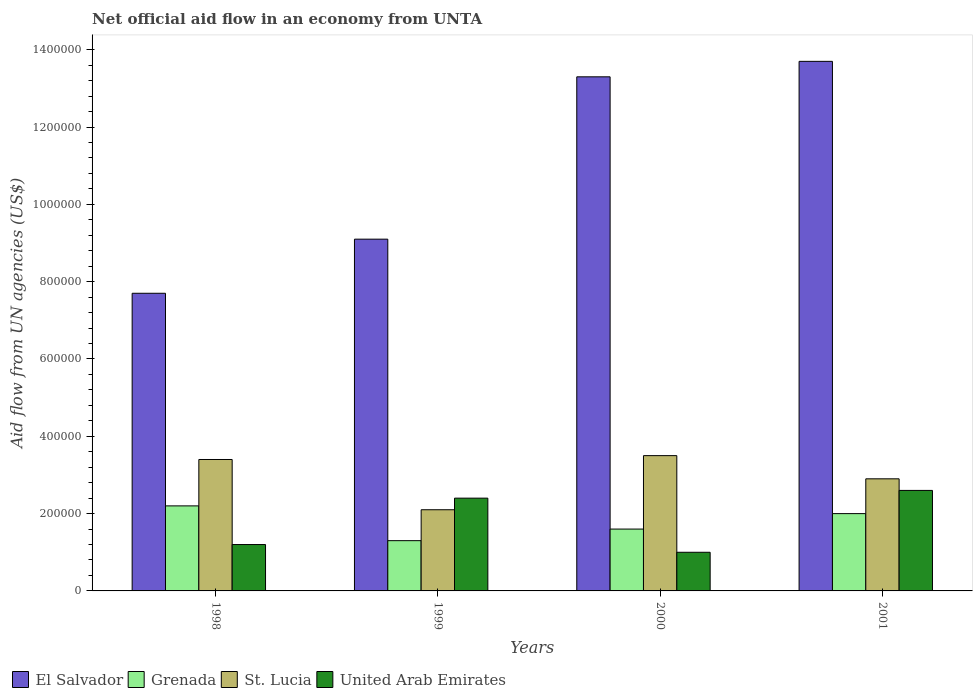How many groups of bars are there?
Give a very brief answer. 4. Are the number of bars per tick equal to the number of legend labels?
Ensure brevity in your answer.  Yes. How many bars are there on the 4th tick from the right?
Give a very brief answer. 4. What is the label of the 3rd group of bars from the left?
Offer a very short reply. 2000. In how many cases, is the number of bars for a given year not equal to the number of legend labels?
Your response must be concise. 0. Across all years, what is the maximum net official aid flow in El Salvador?
Your response must be concise. 1.37e+06. What is the total net official aid flow in Grenada in the graph?
Offer a very short reply. 7.10e+05. What is the difference between the net official aid flow in Grenada in 2000 and the net official aid flow in United Arab Emirates in 2001?
Provide a short and direct response. -1.00e+05. What is the average net official aid flow in United Arab Emirates per year?
Ensure brevity in your answer.  1.80e+05. In the year 2000, what is the difference between the net official aid flow in St. Lucia and net official aid flow in El Salvador?
Make the answer very short. -9.80e+05. In how many years, is the net official aid flow in United Arab Emirates greater than 1160000 US$?
Offer a terse response. 0. What is the ratio of the net official aid flow in El Salvador in 1999 to that in 2000?
Your response must be concise. 0.68. Is the difference between the net official aid flow in St. Lucia in 1999 and 2000 greater than the difference between the net official aid flow in El Salvador in 1999 and 2000?
Your answer should be very brief. Yes. What is the difference between the highest and the second highest net official aid flow in Grenada?
Make the answer very short. 2.00e+04. What is the difference between the highest and the lowest net official aid flow in El Salvador?
Ensure brevity in your answer.  6.00e+05. In how many years, is the net official aid flow in United Arab Emirates greater than the average net official aid flow in United Arab Emirates taken over all years?
Your answer should be very brief. 2. Is it the case that in every year, the sum of the net official aid flow in Grenada and net official aid flow in El Salvador is greater than the sum of net official aid flow in United Arab Emirates and net official aid flow in St. Lucia?
Your answer should be very brief. No. What does the 1st bar from the left in 2001 represents?
Offer a terse response. El Salvador. What does the 4th bar from the right in 1998 represents?
Provide a succinct answer. El Salvador. How many bars are there?
Offer a terse response. 16. How many years are there in the graph?
Give a very brief answer. 4. What is the difference between two consecutive major ticks on the Y-axis?
Provide a succinct answer. 2.00e+05. How are the legend labels stacked?
Your answer should be compact. Horizontal. What is the title of the graph?
Offer a terse response. Net official aid flow in an economy from UNTA. What is the label or title of the X-axis?
Your response must be concise. Years. What is the label or title of the Y-axis?
Give a very brief answer. Aid flow from UN agencies (US$). What is the Aid flow from UN agencies (US$) of El Salvador in 1998?
Provide a short and direct response. 7.70e+05. What is the Aid flow from UN agencies (US$) of St. Lucia in 1998?
Offer a terse response. 3.40e+05. What is the Aid flow from UN agencies (US$) of United Arab Emirates in 1998?
Your answer should be very brief. 1.20e+05. What is the Aid flow from UN agencies (US$) of El Salvador in 1999?
Offer a terse response. 9.10e+05. What is the Aid flow from UN agencies (US$) in Grenada in 1999?
Offer a terse response. 1.30e+05. What is the Aid flow from UN agencies (US$) of El Salvador in 2000?
Give a very brief answer. 1.33e+06. What is the Aid flow from UN agencies (US$) in Grenada in 2000?
Your answer should be compact. 1.60e+05. What is the Aid flow from UN agencies (US$) in United Arab Emirates in 2000?
Provide a short and direct response. 1.00e+05. What is the Aid flow from UN agencies (US$) of El Salvador in 2001?
Provide a succinct answer. 1.37e+06. What is the Aid flow from UN agencies (US$) in Grenada in 2001?
Keep it short and to the point. 2.00e+05. What is the Aid flow from UN agencies (US$) of United Arab Emirates in 2001?
Make the answer very short. 2.60e+05. Across all years, what is the maximum Aid flow from UN agencies (US$) of El Salvador?
Your answer should be compact. 1.37e+06. Across all years, what is the maximum Aid flow from UN agencies (US$) in United Arab Emirates?
Offer a terse response. 2.60e+05. Across all years, what is the minimum Aid flow from UN agencies (US$) of El Salvador?
Offer a terse response. 7.70e+05. Across all years, what is the minimum Aid flow from UN agencies (US$) in St. Lucia?
Provide a short and direct response. 2.10e+05. Across all years, what is the minimum Aid flow from UN agencies (US$) in United Arab Emirates?
Offer a very short reply. 1.00e+05. What is the total Aid flow from UN agencies (US$) of El Salvador in the graph?
Offer a terse response. 4.38e+06. What is the total Aid flow from UN agencies (US$) of Grenada in the graph?
Provide a succinct answer. 7.10e+05. What is the total Aid flow from UN agencies (US$) of St. Lucia in the graph?
Your answer should be compact. 1.19e+06. What is the total Aid flow from UN agencies (US$) in United Arab Emirates in the graph?
Provide a short and direct response. 7.20e+05. What is the difference between the Aid flow from UN agencies (US$) in El Salvador in 1998 and that in 1999?
Offer a terse response. -1.40e+05. What is the difference between the Aid flow from UN agencies (US$) in El Salvador in 1998 and that in 2000?
Keep it short and to the point. -5.60e+05. What is the difference between the Aid flow from UN agencies (US$) of El Salvador in 1998 and that in 2001?
Your answer should be very brief. -6.00e+05. What is the difference between the Aid flow from UN agencies (US$) in Grenada in 1998 and that in 2001?
Your answer should be compact. 2.00e+04. What is the difference between the Aid flow from UN agencies (US$) in St. Lucia in 1998 and that in 2001?
Your answer should be compact. 5.00e+04. What is the difference between the Aid flow from UN agencies (US$) of United Arab Emirates in 1998 and that in 2001?
Offer a very short reply. -1.40e+05. What is the difference between the Aid flow from UN agencies (US$) of El Salvador in 1999 and that in 2000?
Your answer should be compact. -4.20e+05. What is the difference between the Aid flow from UN agencies (US$) of St. Lucia in 1999 and that in 2000?
Your answer should be compact. -1.40e+05. What is the difference between the Aid flow from UN agencies (US$) of El Salvador in 1999 and that in 2001?
Your response must be concise. -4.60e+05. What is the difference between the Aid flow from UN agencies (US$) of El Salvador in 2000 and that in 2001?
Give a very brief answer. -4.00e+04. What is the difference between the Aid flow from UN agencies (US$) in Grenada in 2000 and that in 2001?
Your response must be concise. -4.00e+04. What is the difference between the Aid flow from UN agencies (US$) of El Salvador in 1998 and the Aid flow from UN agencies (US$) of Grenada in 1999?
Provide a short and direct response. 6.40e+05. What is the difference between the Aid flow from UN agencies (US$) in El Salvador in 1998 and the Aid flow from UN agencies (US$) in St. Lucia in 1999?
Your answer should be compact. 5.60e+05. What is the difference between the Aid flow from UN agencies (US$) in El Salvador in 1998 and the Aid flow from UN agencies (US$) in United Arab Emirates in 1999?
Offer a terse response. 5.30e+05. What is the difference between the Aid flow from UN agencies (US$) of Grenada in 1998 and the Aid flow from UN agencies (US$) of United Arab Emirates in 1999?
Ensure brevity in your answer.  -2.00e+04. What is the difference between the Aid flow from UN agencies (US$) in El Salvador in 1998 and the Aid flow from UN agencies (US$) in St. Lucia in 2000?
Your answer should be compact. 4.20e+05. What is the difference between the Aid flow from UN agencies (US$) in El Salvador in 1998 and the Aid flow from UN agencies (US$) in United Arab Emirates in 2000?
Provide a short and direct response. 6.70e+05. What is the difference between the Aid flow from UN agencies (US$) of St. Lucia in 1998 and the Aid flow from UN agencies (US$) of United Arab Emirates in 2000?
Provide a succinct answer. 2.40e+05. What is the difference between the Aid flow from UN agencies (US$) of El Salvador in 1998 and the Aid flow from UN agencies (US$) of Grenada in 2001?
Give a very brief answer. 5.70e+05. What is the difference between the Aid flow from UN agencies (US$) of El Salvador in 1998 and the Aid flow from UN agencies (US$) of St. Lucia in 2001?
Your answer should be very brief. 4.80e+05. What is the difference between the Aid flow from UN agencies (US$) of El Salvador in 1998 and the Aid flow from UN agencies (US$) of United Arab Emirates in 2001?
Offer a terse response. 5.10e+05. What is the difference between the Aid flow from UN agencies (US$) of Grenada in 1998 and the Aid flow from UN agencies (US$) of United Arab Emirates in 2001?
Your answer should be very brief. -4.00e+04. What is the difference between the Aid flow from UN agencies (US$) of El Salvador in 1999 and the Aid flow from UN agencies (US$) of Grenada in 2000?
Provide a succinct answer. 7.50e+05. What is the difference between the Aid flow from UN agencies (US$) in El Salvador in 1999 and the Aid flow from UN agencies (US$) in St. Lucia in 2000?
Your answer should be very brief. 5.60e+05. What is the difference between the Aid flow from UN agencies (US$) in El Salvador in 1999 and the Aid flow from UN agencies (US$) in United Arab Emirates in 2000?
Provide a short and direct response. 8.10e+05. What is the difference between the Aid flow from UN agencies (US$) in Grenada in 1999 and the Aid flow from UN agencies (US$) in United Arab Emirates in 2000?
Your answer should be very brief. 3.00e+04. What is the difference between the Aid flow from UN agencies (US$) of St. Lucia in 1999 and the Aid flow from UN agencies (US$) of United Arab Emirates in 2000?
Your answer should be compact. 1.10e+05. What is the difference between the Aid flow from UN agencies (US$) of El Salvador in 1999 and the Aid flow from UN agencies (US$) of Grenada in 2001?
Keep it short and to the point. 7.10e+05. What is the difference between the Aid flow from UN agencies (US$) in El Salvador in 1999 and the Aid flow from UN agencies (US$) in St. Lucia in 2001?
Your response must be concise. 6.20e+05. What is the difference between the Aid flow from UN agencies (US$) of El Salvador in 1999 and the Aid flow from UN agencies (US$) of United Arab Emirates in 2001?
Your answer should be compact. 6.50e+05. What is the difference between the Aid flow from UN agencies (US$) in Grenada in 1999 and the Aid flow from UN agencies (US$) in St. Lucia in 2001?
Ensure brevity in your answer.  -1.60e+05. What is the difference between the Aid flow from UN agencies (US$) of Grenada in 1999 and the Aid flow from UN agencies (US$) of United Arab Emirates in 2001?
Give a very brief answer. -1.30e+05. What is the difference between the Aid flow from UN agencies (US$) in El Salvador in 2000 and the Aid flow from UN agencies (US$) in Grenada in 2001?
Provide a short and direct response. 1.13e+06. What is the difference between the Aid flow from UN agencies (US$) of El Salvador in 2000 and the Aid flow from UN agencies (US$) of St. Lucia in 2001?
Your answer should be very brief. 1.04e+06. What is the difference between the Aid flow from UN agencies (US$) of El Salvador in 2000 and the Aid flow from UN agencies (US$) of United Arab Emirates in 2001?
Provide a succinct answer. 1.07e+06. What is the difference between the Aid flow from UN agencies (US$) of St. Lucia in 2000 and the Aid flow from UN agencies (US$) of United Arab Emirates in 2001?
Provide a short and direct response. 9.00e+04. What is the average Aid flow from UN agencies (US$) of El Salvador per year?
Make the answer very short. 1.10e+06. What is the average Aid flow from UN agencies (US$) of Grenada per year?
Offer a terse response. 1.78e+05. What is the average Aid flow from UN agencies (US$) of St. Lucia per year?
Provide a succinct answer. 2.98e+05. In the year 1998, what is the difference between the Aid flow from UN agencies (US$) in El Salvador and Aid flow from UN agencies (US$) in Grenada?
Give a very brief answer. 5.50e+05. In the year 1998, what is the difference between the Aid flow from UN agencies (US$) of El Salvador and Aid flow from UN agencies (US$) of St. Lucia?
Make the answer very short. 4.30e+05. In the year 1998, what is the difference between the Aid flow from UN agencies (US$) in El Salvador and Aid flow from UN agencies (US$) in United Arab Emirates?
Provide a succinct answer. 6.50e+05. In the year 1998, what is the difference between the Aid flow from UN agencies (US$) in Grenada and Aid flow from UN agencies (US$) in United Arab Emirates?
Your response must be concise. 1.00e+05. In the year 1999, what is the difference between the Aid flow from UN agencies (US$) in El Salvador and Aid flow from UN agencies (US$) in Grenada?
Give a very brief answer. 7.80e+05. In the year 1999, what is the difference between the Aid flow from UN agencies (US$) of El Salvador and Aid flow from UN agencies (US$) of St. Lucia?
Your response must be concise. 7.00e+05. In the year 1999, what is the difference between the Aid flow from UN agencies (US$) of El Salvador and Aid flow from UN agencies (US$) of United Arab Emirates?
Your response must be concise. 6.70e+05. In the year 1999, what is the difference between the Aid flow from UN agencies (US$) of Grenada and Aid flow from UN agencies (US$) of United Arab Emirates?
Make the answer very short. -1.10e+05. In the year 2000, what is the difference between the Aid flow from UN agencies (US$) in El Salvador and Aid flow from UN agencies (US$) in Grenada?
Offer a terse response. 1.17e+06. In the year 2000, what is the difference between the Aid flow from UN agencies (US$) in El Salvador and Aid flow from UN agencies (US$) in St. Lucia?
Your answer should be very brief. 9.80e+05. In the year 2000, what is the difference between the Aid flow from UN agencies (US$) of El Salvador and Aid flow from UN agencies (US$) of United Arab Emirates?
Make the answer very short. 1.23e+06. In the year 2000, what is the difference between the Aid flow from UN agencies (US$) of Grenada and Aid flow from UN agencies (US$) of St. Lucia?
Offer a terse response. -1.90e+05. In the year 2000, what is the difference between the Aid flow from UN agencies (US$) in Grenada and Aid flow from UN agencies (US$) in United Arab Emirates?
Give a very brief answer. 6.00e+04. In the year 2000, what is the difference between the Aid flow from UN agencies (US$) in St. Lucia and Aid flow from UN agencies (US$) in United Arab Emirates?
Offer a terse response. 2.50e+05. In the year 2001, what is the difference between the Aid flow from UN agencies (US$) of El Salvador and Aid flow from UN agencies (US$) of Grenada?
Give a very brief answer. 1.17e+06. In the year 2001, what is the difference between the Aid flow from UN agencies (US$) in El Salvador and Aid flow from UN agencies (US$) in St. Lucia?
Make the answer very short. 1.08e+06. In the year 2001, what is the difference between the Aid flow from UN agencies (US$) in El Salvador and Aid flow from UN agencies (US$) in United Arab Emirates?
Make the answer very short. 1.11e+06. In the year 2001, what is the difference between the Aid flow from UN agencies (US$) in Grenada and Aid flow from UN agencies (US$) in United Arab Emirates?
Your answer should be compact. -6.00e+04. What is the ratio of the Aid flow from UN agencies (US$) in El Salvador in 1998 to that in 1999?
Your response must be concise. 0.85. What is the ratio of the Aid flow from UN agencies (US$) in Grenada in 1998 to that in 1999?
Your response must be concise. 1.69. What is the ratio of the Aid flow from UN agencies (US$) in St. Lucia in 1998 to that in 1999?
Your response must be concise. 1.62. What is the ratio of the Aid flow from UN agencies (US$) in United Arab Emirates in 1998 to that in 1999?
Your answer should be very brief. 0.5. What is the ratio of the Aid flow from UN agencies (US$) of El Salvador in 1998 to that in 2000?
Your response must be concise. 0.58. What is the ratio of the Aid flow from UN agencies (US$) of Grenada in 1998 to that in 2000?
Your answer should be very brief. 1.38. What is the ratio of the Aid flow from UN agencies (US$) in St. Lucia in 1998 to that in 2000?
Keep it short and to the point. 0.97. What is the ratio of the Aid flow from UN agencies (US$) in United Arab Emirates in 1998 to that in 2000?
Offer a terse response. 1.2. What is the ratio of the Aid flow from UN agencies (US$) in El Salvador in 1998 to that in 2001?
Keep it short and to the point. 0.56. What is the ratio of the Aid flow from UN agencies (US$) of St. Lucia in 1998 to that in 2001?
Give a very brief answer. 1.17. What is the ratio of the Aid flow from UN agencies (US$) of United Arab Emirates in 1998 to that in 2001?
Keep it short and to the point. 0.46. What is the ratio of the Aid flow from UN agencies (US$) of El Salvador in 1999 to that in 2000?
Make the answer very short. 0.68. What is the ratio of the Aid flow from UN agencies (US$) in Grenada in 1999 to that in 2000?
Keep it short and to the point. 0.81. What is the ratio of the Aid flow from UN agencies (US$) in St. Lucia in 1999 to that in 2000?
Ensure brevity in your answer.  0.6. What is the ratio of the Aid flow from UN agencies (US$) in United Arab Emirates in 1999 to that in 2000?
Make the answer very short. 2.4. What is the ratio of the Aid flow from UN agencies (US$) in El Salvador in 1999 to that in 2001?
Provide a short and direct response. 0.66. What is the ratio of the Aid flow from UN agencies (US$) in Grenada in 1999 to that in 2001?
Your answer should be very brief. 0.65. What is the ratio of the Aid flow from UN agencies (US$) in St. Lucia in 1999 to that in 2001?
Ensure brevity in your answer.  0.72. What is the ratio of the Aid flow from UN agencies (US$) in El Salvador in 2000 to that in 2001?
Provide a succinct answer. 0.97. What is the ratio of the Aid flow from UN agencies (US$) of Grenada in 2000 to that in 2001?
Provide a succinct answer. 0.8. What is the ratio of the Aid flow from UN agencies (US$) of St. Lucia in 2000 to that in 2001?
Give a very brief answer. 1.21. What is the ratio of the Aid flow from UN agencies (US$) of United Arab Emirates in 2000 to that in 2001?
Offer a very short reply. 0.38. What is the difference between the highest and the second highest Aid flow from UN agencies (US$) of Grenada?
Provide a succinct answer. 2.00e+04. What is the difference between the highest and the lowest Aid flow from UN agencies (US$) in El Salvador?
Offer a very short reply. 6.00e+05. What is the difference between the highest and the lowest Aid flow from UN agencies (US$) in Grenada?
Make the answer very short. 9.00e+04. 